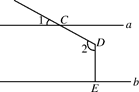First perform reasoning, then finally select the question from the choices in the following format: Answer: xxx.
Question: In the provided diagram, let's represent angle 1 as variable u where u = 25.0 degrees. What is the degree measure of angle 2, expressed as variable v in relation to u?
Choices:
A: 115°
B: 125°
C: 155°
D: 165° To determine the value of v, the degree measure of angle 2, we can use the geometric properties of the figure. Angle 1 is equal to angle CDB, which is denoted as angle u. Additionally, line a is parallel to line b, and line segment DE is perpendicular to line b, implying that line b is parallel to line c, and line segment DE is perpendicular to line C. Therefore, angle 2 is equal to angle CDB plus 90 degrees, represented as angle u + 90 degrees. Substituting the given value of u, we have v = 25.0 degrees + 90 degrees. Evaluating this expression, v = 115.0 degrees. Therefore, the degree measure of angle 2 is 115.0 degrees. Hence, the answer is option A.
Answer:A 